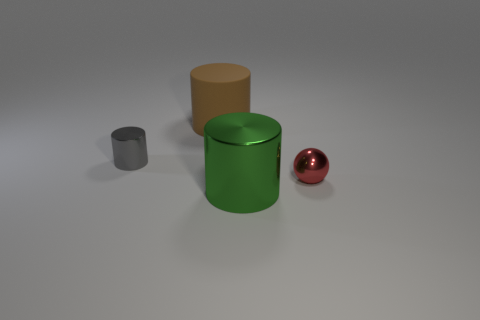Subtract all big shiny cylinders. How many cylinders are left? 2 Add 2 cyan metallic spheres. How many objects exist? 6 Subtract all cylinders. How many objects are left? 1 Add 2 large purple cubes. How many large purple cubes exist? 2 Subtract 0 purple blocks. How many objects are left? 4 Subtract all cyan blocks. Subtract all small red objects. How many objects are left? 3 Add 1 rubber objects. How many rubber objects are left? 2 